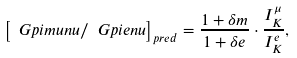Convert formula to latex. <formula><loc_0><loc_0><loc_500><loc_500>\left [ \ G p i m u n u / \ G p i e n u \right ] _ { p r e d } = \frac { 1 + \delta m } { 1 + \delta e } \cdot \frac { I _ { K } ^ { \mu } } { I _ { K } ^ { e } } ,</formula> 